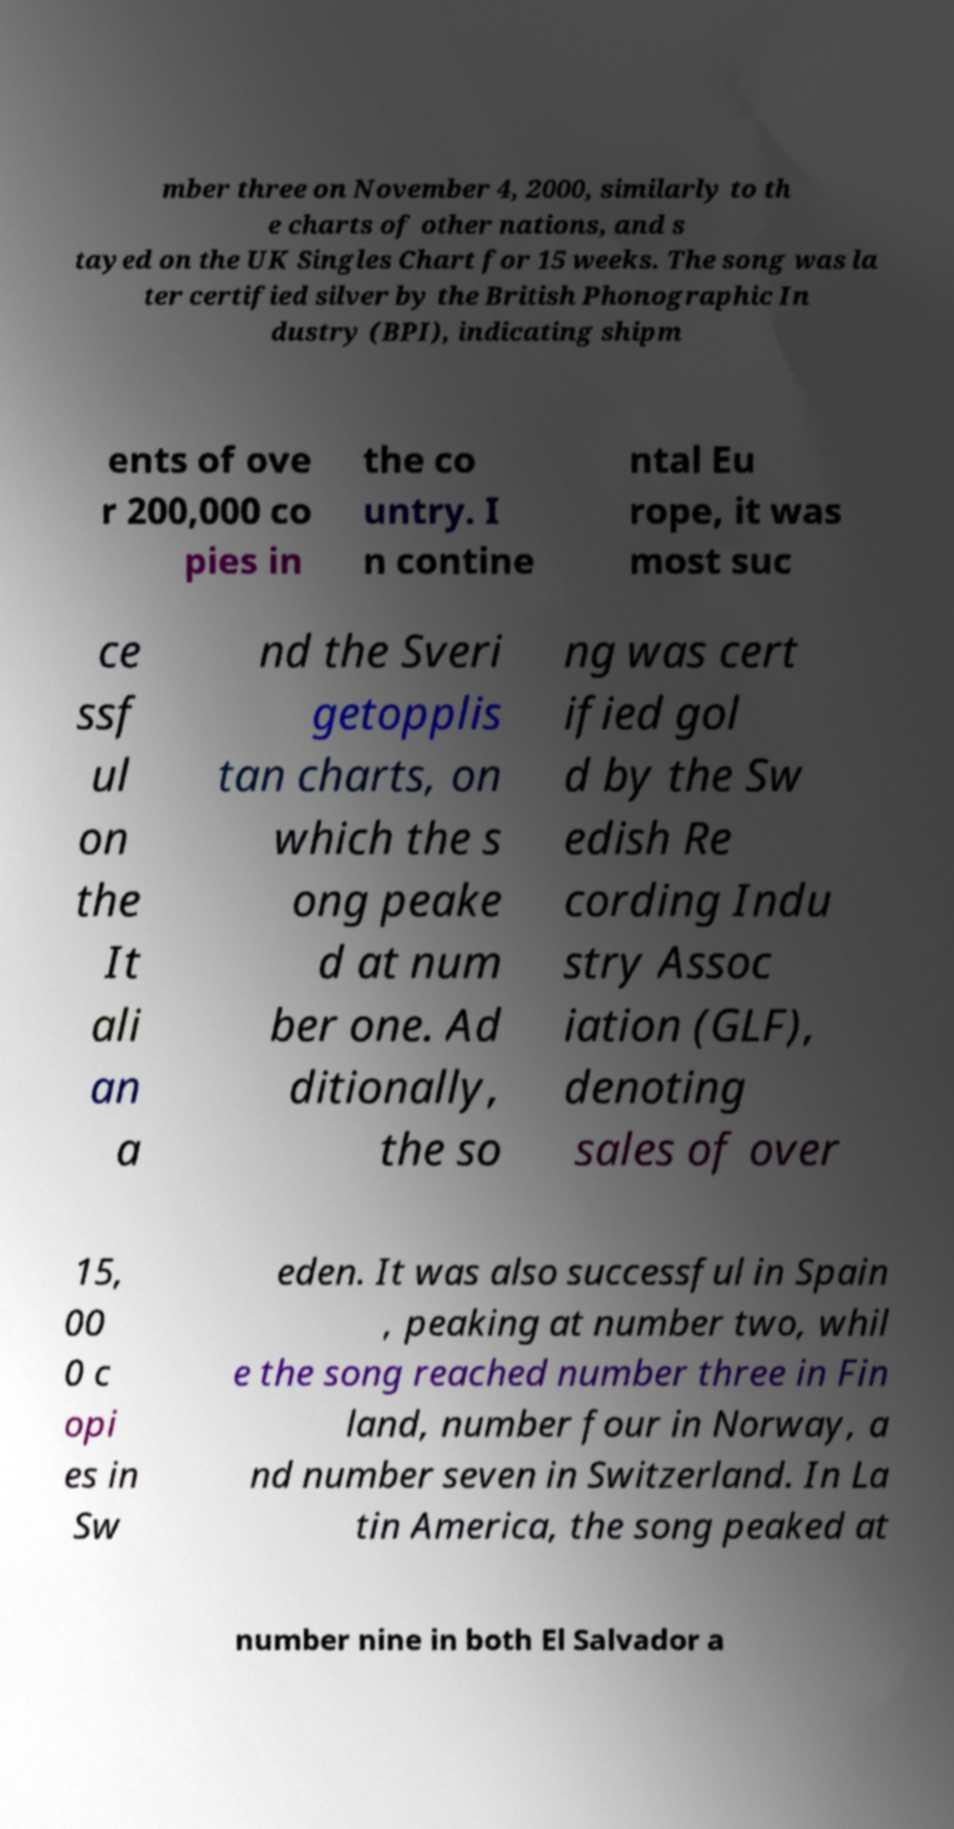What messages or text are displayed in this image? I need them in a readable, typed format. mber three on November 4, 2000, similarly to th e charts of other nations, and s tayed on the UK Singles Chart for 15 weeks. The song was la ter certified silver by the British Phonographic In dustry (BPI), indicating shipm ents of ove r 200,000 co pies in the co untry. I n contine ntal Eu rope, it was most suc ce ssf ul on the It ali an a nd the Sveri getopplis tan charts, on which the s ong peake d at num ber one. Ad ditionally, the so ng was cert ified gol d by the Sw edish Re cording Indu stry Assoc iation (GLF), denoting sales of over 15, 00 0 c opi es in Sw eden. It was also successful in Spain , peaking at number two, whil e the song reached number three in Fin land, number four in Norway, a nd number seven in Switzerland. In La tin America, the song peaked at number nine in both El Salvador a 